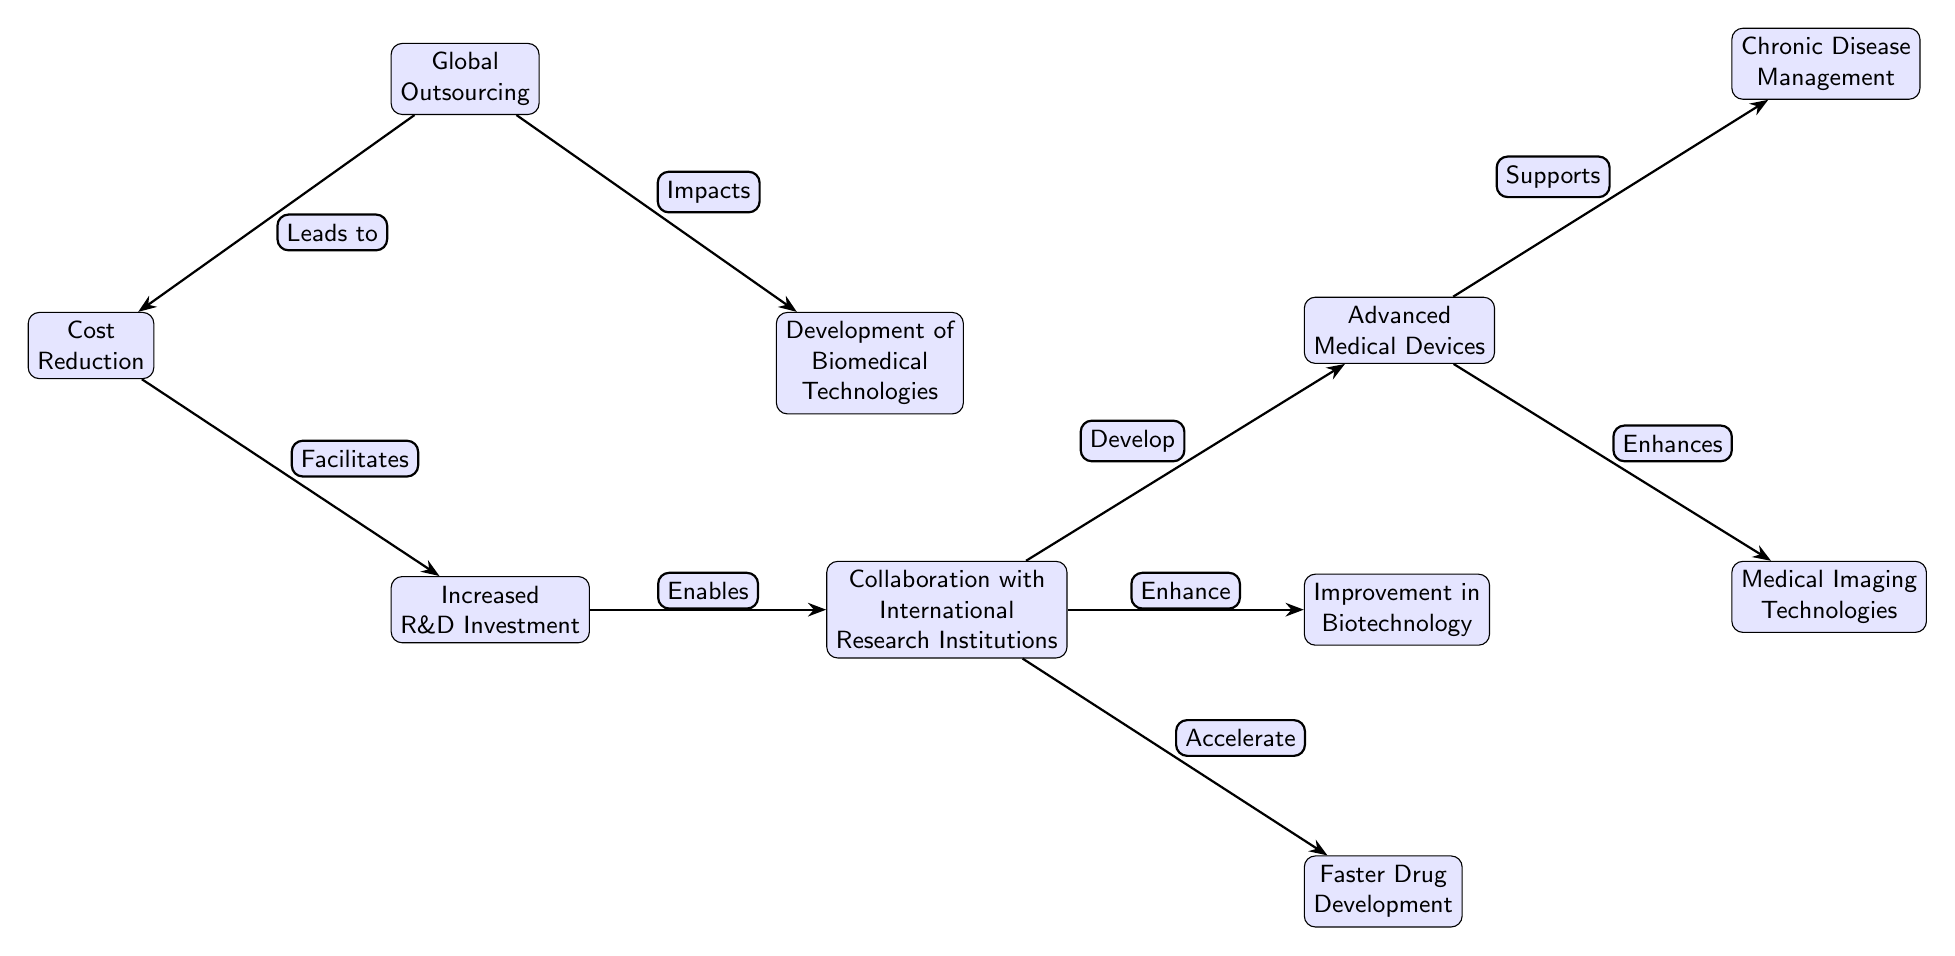What is the main focus of the diagram? The diagram depicts the "Development of Biomedical Technologies". It's the central node in the diagram, connecting various elements related to biomedical advancements and the influence of globalization.
Answer: Development of Biomedical Technologies How many nodes are in the diagram? There are a total of ten nodes visually represented in the diagram, including the main focus and its various influences and outcomes.
Answer: 10 What does global outsourcing lead to in the diagram? Global outsourcing leads to "Cost Reduction" as indicated by the direct edge connecting the two nodes, showing that outsourcing primarily aims at reducing expenses.
Answer: Cost Reduction Which element supports chronic disease management? "Advanced Medical Devices" support chronic disease management as shown by the connection from the advanced technologies offering practical solutions for long-term health issues.
Answer: Advanced Medical Devices What is one of the impacts of global outsourcing on biomedical technologies? One significant impact of global outsourcing on biomedical technologies is outlined as the development of these technologies, highlighting how outsourcing contributes to advancements.
Answer: Development of Biomedical Technologies What role does increased research and development investment play? Increased R&D investment enables collaboration with international research institutions, emphasizing how funding impacts partnerships in the research community.
Answer: Collaboration with International Research Institutions How does increased research and development investment relate to faster drug development? Increased R&D investment accelerates the process of drug development through enhanced collaborations, indicating that more funds lead to quicker advancements in therapies and medications.
Answer: Faster Drug Development What type of biotechnological enhancement is mentioned in the diagram? The enhancement in biotechnology specifically refers to "Improvement in Biotechnology", which indicates that globalization positively affects technological advancements in this field.
Answer: Improvement in Biotechnology Which two advanced technologies are connected to advanced medical devices? The two advanced technologies linked to advanced medical devices are "Chronic Disease Management" and "Medical Imaging Technologies", indicating their reliance on these devices for function.
Answer: Chronic Disease Management, Medical Imaging Technologies 